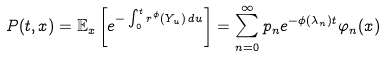Convert formula to latex. <formula><loc_0><loc_0><loc_500><loc_500>P ( t , x ) = { \mathbb { E } } _ { x } \left [ e ^ { - \int _ { 0 } ^ { t } r ^ { \phi } ( Y _ { u } ) \, d u } \right ] = \sum _ { n = 0 } ^ { \infty } p _ { n } e ^ { - \phi ( \lambda _ { n } ) t } \varphi _ { n } ( x )</formula> 